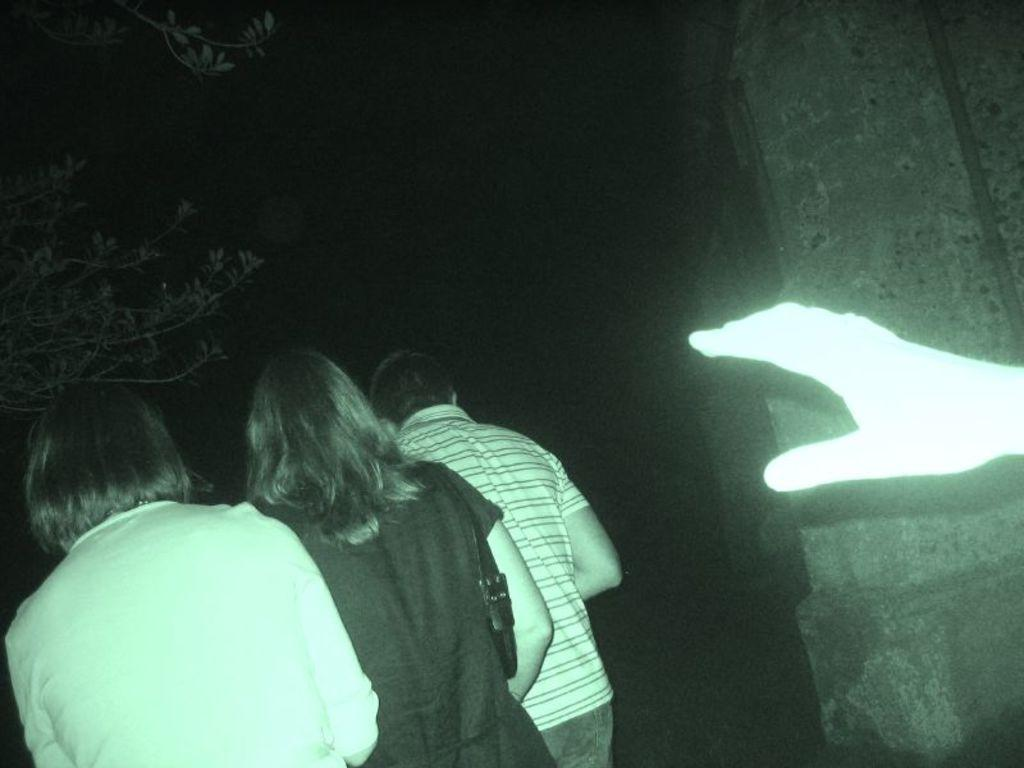How many people are in the image? There are three persons standing in the bottom left corner of the image. What is located behind the three persons? There is a tree behind the three persons. What can be seen on the right side of the image? There is a hand on the right side of the image. What is located behind the hand? There is a wall behind the hand. What type of wool can be seen blowing in the zephyr in the image? There is no wool or zephyr present in the image. 